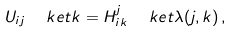<formula> <loc_0><loc_0><loc_500><loc_500>U _ { i j } \ \ k e t k = H ^ { j } _ { i k } \ \ k e t { \lambda ( j , k ) } \, ,</formula> 